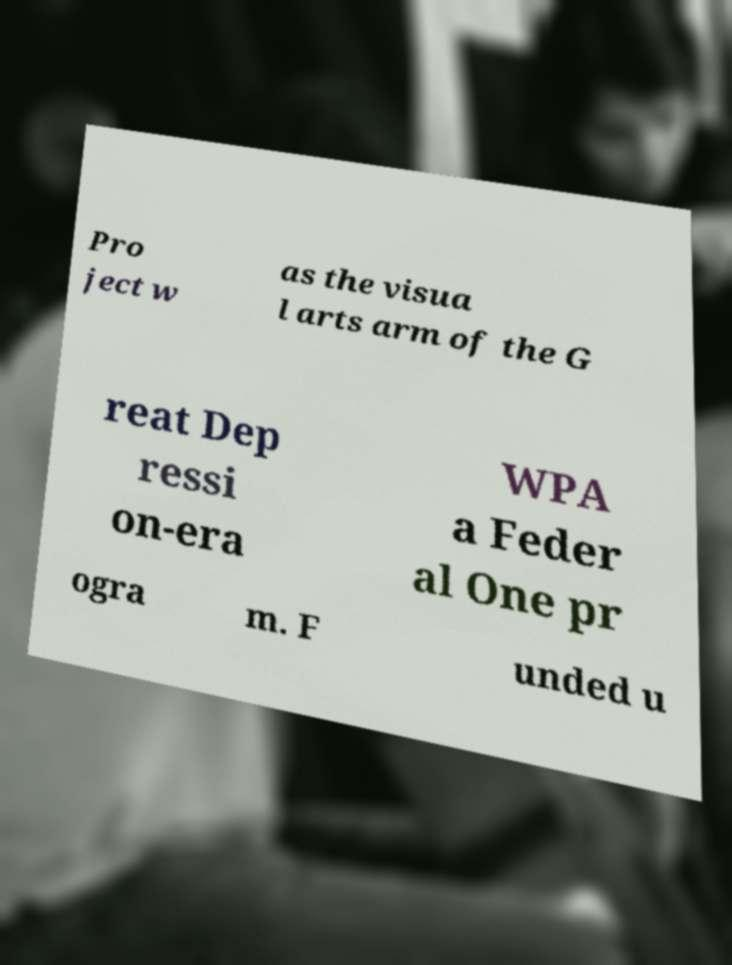For documentation purposes, I need the text within this image transcribed. Could you provide that? Pro ject w as the visua l arts arm of the G reat Dep ressi on-era WPA a Feder al One pr ogra m. F unded u 